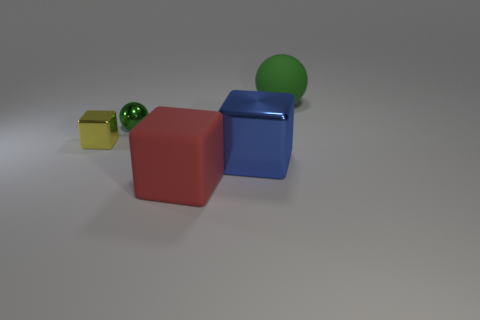What number of other things are there of the same color as the big matte cube?
Give a very brief answer. 0. Does the shiny cube right of the yellow shiny cube have the same size as the sphere behind the small metallic sphere?
Offer a terse response. Yes. There is a metal object that is in front of the tiny yellow metallic thing; what color is it?
Offer a very short reply. Blue. Are there fewer yellow cubes behind the shiny ball than yellow cubes?
Give a very brief answer. Yes. Is the material of the tiny sphere the same as the big ball?
Offer a very short reply. No. What is the size of the other green thing that is the same shape as the small green object?
Make the answer very short. Large. How many things are blocks behind the red object or green balls that are in front of the large green matte object?
Provide a succinct answer. 3. Are there fewer red cubes than big brown cylinders?
Provide a succinct answer. No. Do the green matte ball and the green thing in front of the green rubber object have the same size?
Make the answer very short. No. How many metallic objects are either large green cylinders or big cubes?
Make the answer very short. 1. 